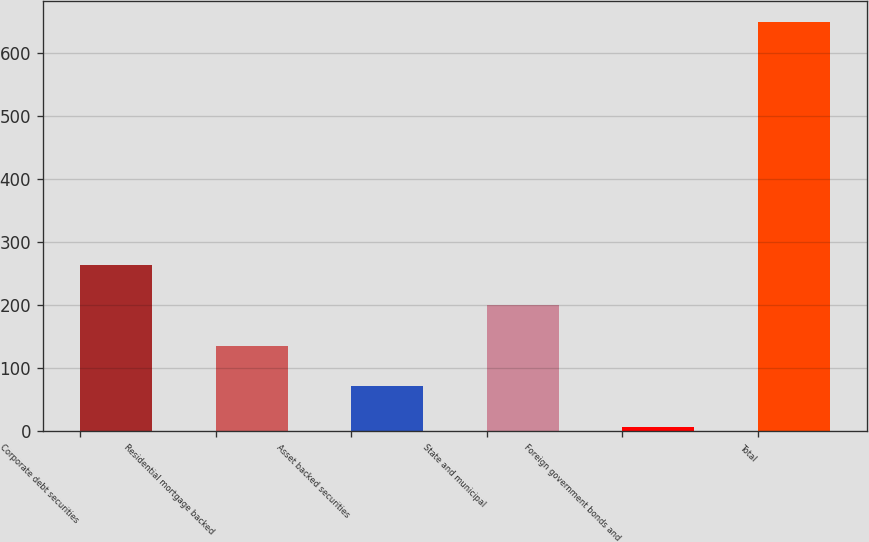Convert chart to OTSL. <chart><loc_0><loc_0><loc_500><loc_500><bar_chart><fcel>Corporate debt securities<fcel>Residential mortgage backed<fcel>Asset backed securities<fcel>State and municipal<fcel>Foreign government bonds and<fcel>Total<nl><fcel>264.2<fcel>135.6<fcel>71.3<fcel>199.9<fcel>7<fcel>650<nl></chart> 